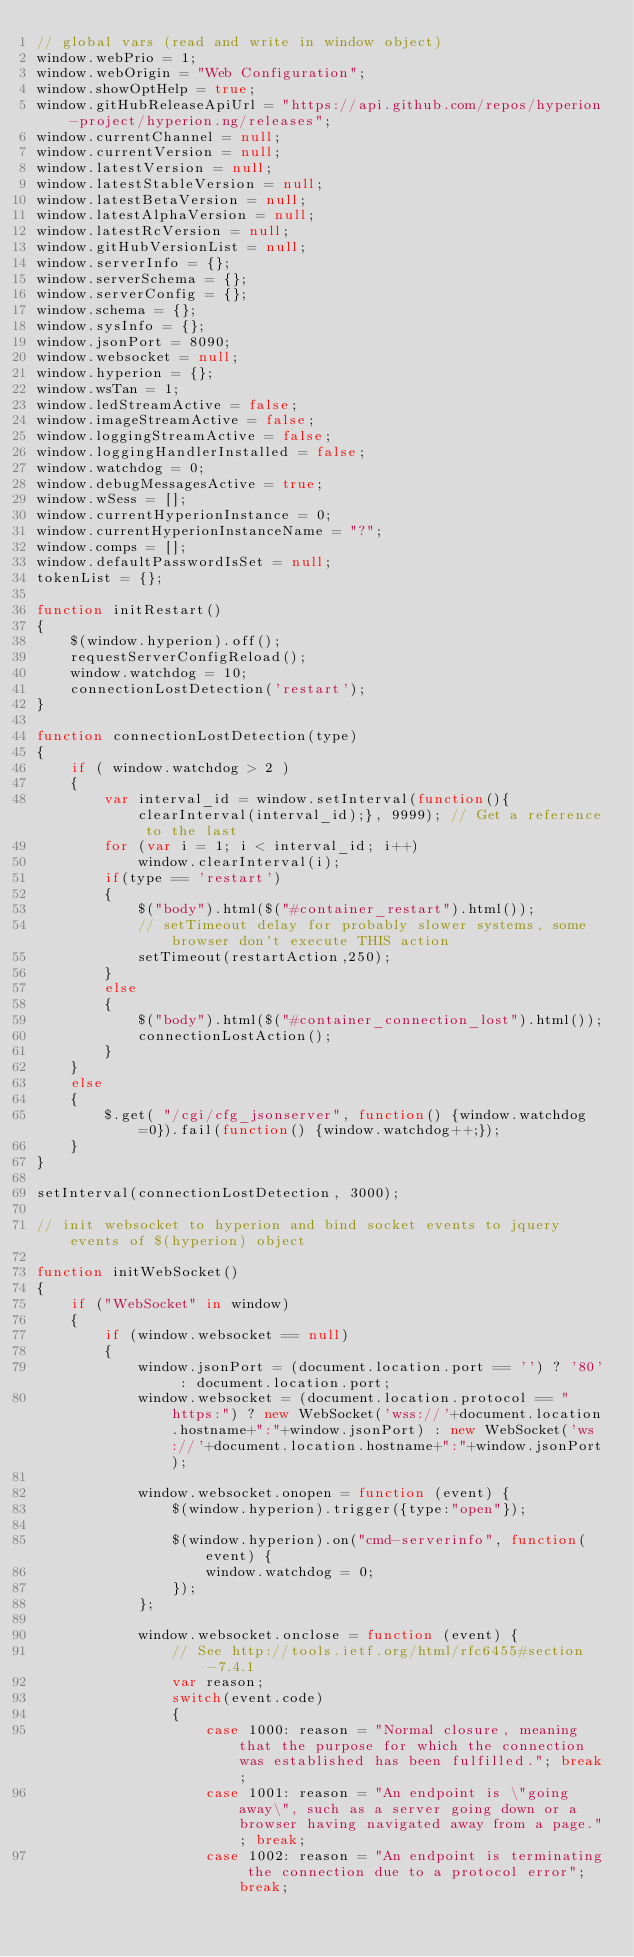<code> <loc_0><loc_0><loc_500><loc_500><_JavaScript_>// global vars (read and write in window object)
window.webPrio = 1;
window.webOrigin = "Web Configuration";
window.showOptHelp = true;
window.gitHubReleaseApiUrl = "https://api.github.com/repos/hyperion-project/hyperion.ng/releases";
window.currentChannel = null;
window.currentVersion = null;
window.latestVersion = null;
window.latestStableVersion = null;
window.latestBetaVersion = null;
window.latestAlphaVersion = null;
window.latestRcVersion = null;
window.gitHubVersionList = null;
window.serverInfo = {};
window.serverSchema = {};
window.serverConfig = {};
window.schema = {};
window.sysInfo = {};
window.jsonPort = 8090;
window.websocket = null;
window.hyperion = {};
window.wsTan = 1;
window.ledStreamActive = false;
window.imageStreamActive = false;
window.loggingStreamActive = false;
window.loggingHandlerInstalled = false;
window.watchdog = 0;
window.debugMessagesActive = true;
window.wSess = [];
window.currentHyperionInstance = 0;
window.currentHyperionInstanceName = "?";
window.comps = [];
window.defaultPasswordIsSet = null;
tokenList = {};

function initRestart()
{
	$(window.hyperion).off();
	requestServerConfigReload();
	window.watchdog = 10;
	connectionLostDetection('restart');
}

function connectionLostDetection(type)
{
	if ( window.watchdog > 2 )
	{
		var interval_id = window.setInterval(function(){clearInterval(interval_id);}, 9999); // Get a reference to the last
		for (var i = 1; i < interval_id; i++)
			window.clearInterval(i);
		if(type == 'restart')
		{
			$("body").html($("#container_restart").html());
			// setTimeout delay for probably slower systems, some browser don't execute THIS action
			setTimeout(restartAction,250);
		}
		else
		{
			$("body").html($("#container_connection_lost").html());
			connectionLostAction();
		}
	}
	else
	{
		$.get( "/cgi/cfg_jsonserver", function() {window.watchdog=0}).fail(function() {window.watchdog++;});
	}
}

setInterval(connectionLostDetection, 3000);

// init websocket to hyperion and bind socket events to jquery events of $(hyperion) object

function initWebSocket()
{
	if ("WebSocket" in window)
	{
		if (window.websocket == null)
		{
			window.jsonPort = (document.location.port == '') ? '80' : document.location.port;
			window.websocket = (document.location.protocol == "https:") ? new WebSocket('wss://'+document.location.hostname+":"+window.jsonPort) : new WebSocket('ws://'+document.location.hostname+":"+window.jsonPort);

			window.websocket.onopen = function (event) {
				$(window.hyperion).trigger({type:"open"});

				$(window.hyperion).on("cmd-serverinfo", function(event) {
					window.watchdog = 0;
				});
			};

			window.websocket.onclose = function (event) {
				// See http://tools.ietf.org/html/rfc6455#section-7.4.1
				var reason;
				switch(event.code)
				{
					case 1000: reason = "Normal closure, meaning that the purpose for which the connection was established has been fulfilled."; break;
					case 1001: reason = "An endpoint is \"going away\", such as a server going down or a browser having navigated away from a page."; break;
					case 1002: reason = "An endpoint is terminating the connection due to a protocol error"; break;</code> 